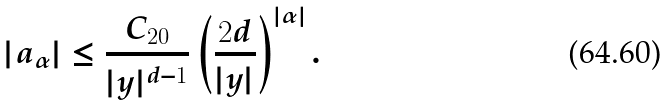Convert formula to latex. <formula><loc_0><loc_0><loc_500><loc_500>| a _ { \alpha } | \leq \frac { C _ { 2 0 } } { | y | ^ { d - 1 } } \left ( \frac { 2 d } { | y | } \right ) ^ { | \alpha | } .</formula> 